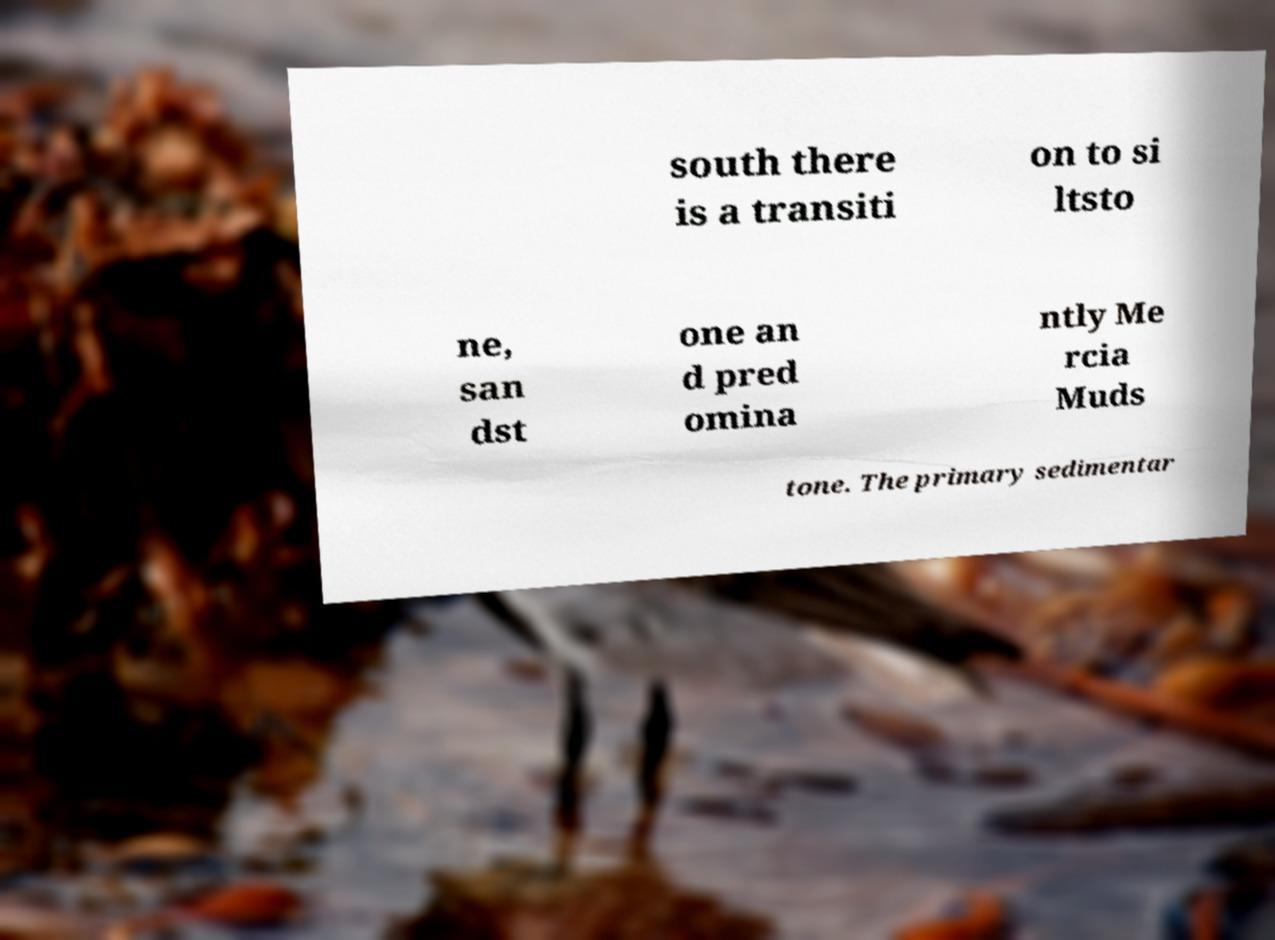Could you extract and type out the text from this image? south there is a transiti on to si ltsto ne, san dst one an d pred omina ntly Me rcia Muds tone. The primary sedimentar 